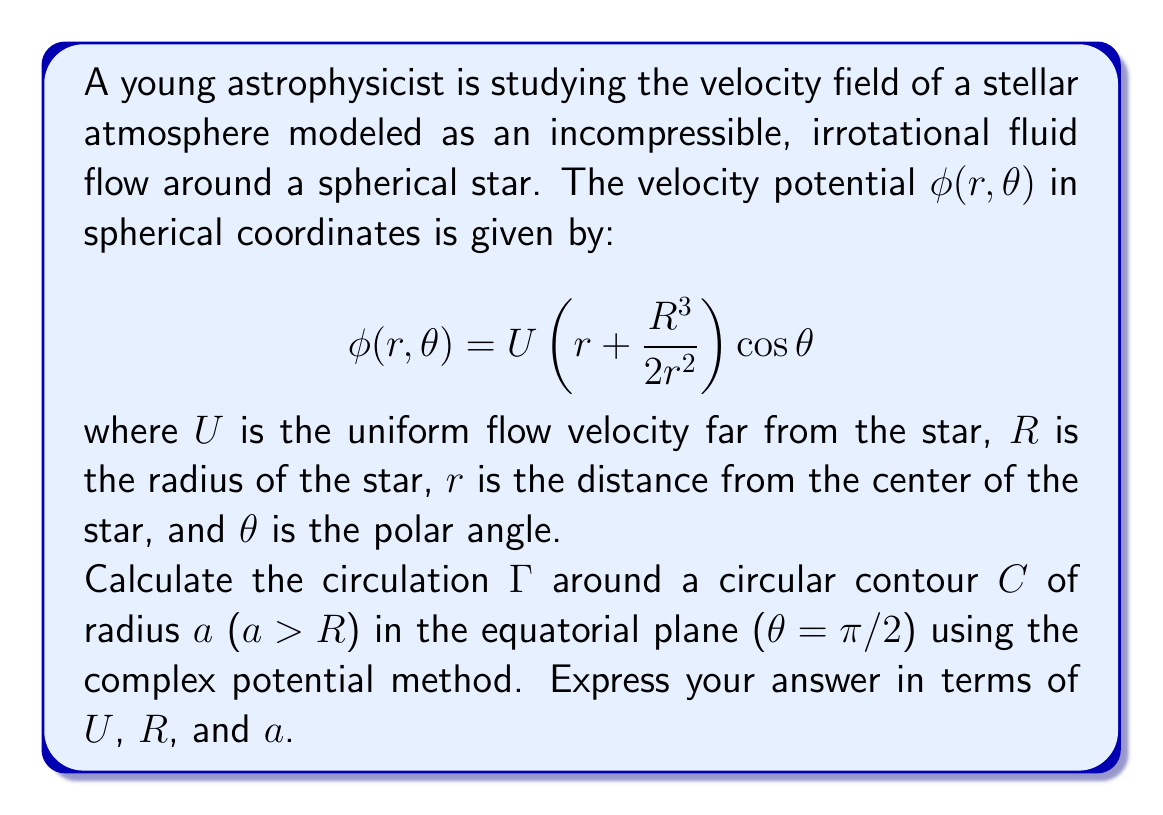Can you solve this math problem? Let's approach this problem step-by-step:

1) First, we need to recognize that the circulation $\Gamma$ is given by the line integral of velocity around the contour:

   $$\Gamma = \oint_C \vec{v} \cdot d\vec{l}$$

2) In complex analysis, we can use the complex potential $w(z) = \phi + i\psi$, where $\phi$ is the velocity potential and $\psi$ is the stream function. The velocity components are given by:

   $$v_x - iv_y = \frac{dw}{dz}$$

3) To find the complex potential, we need to convert the given velocity potential to complex form. In the $xy$-plane ($\theta = \pi/2$), we have $x = r\cos\phi$ and $y = r\sin\phi$. Using $z = x + iy = re^{i\phi}$, we can write:

   $$w(z) = U\left(z + \frac{R^3}{2z^2}\right)$$

4) Now, we can calculate $\frac{dw}{dz}$:

   $$\frac{dw}{dz} = U\left(1 - \frac{R^3}{z^3}\right)$$

5) The circulation is given by:

   $$\Gamma = \oint_C (v_x dx + v_y dy) = -i\oint_C (v_x - iv_y)dz = -i\oint_C \frac{dw}{dz}dz$$

6) Substituting the expression for $\frac{dw}{dz}$:

   $$\Gamma = -iU\oint_C \left(1 - \frac{R^3}{z^3}\right)dz$$

7) On the circular contour of radius $a$, we can parametrize $z = ae^{i\theta}$, $dz = iae^{i\theta}d\theta$, with $\theta$ going from 0 to $2\pi$:

   $$\Gamma = -iU\int_0^{2\pi} \left(1 - \frac{R^3}{a^3e^{3i\theta}}\right)iae^{i\theta}d\theta$$

8) Simplifying:

   $$\Gamma = U\int_0^{2\pi} \left(a - \frac{R^3}{a^2e^{2i\theta}}\right)d\theta$$

9) The first term integrates to $2\pi a$. The second term becomes zero because $\int_0^{2\pi} e^{-2i\theta}d\theta = 0$.

10) Therefore, the final result is:

    $$\Gamma = 2\pi aU$$
Answer: $$\Gamma = 2\pi aU$$ 